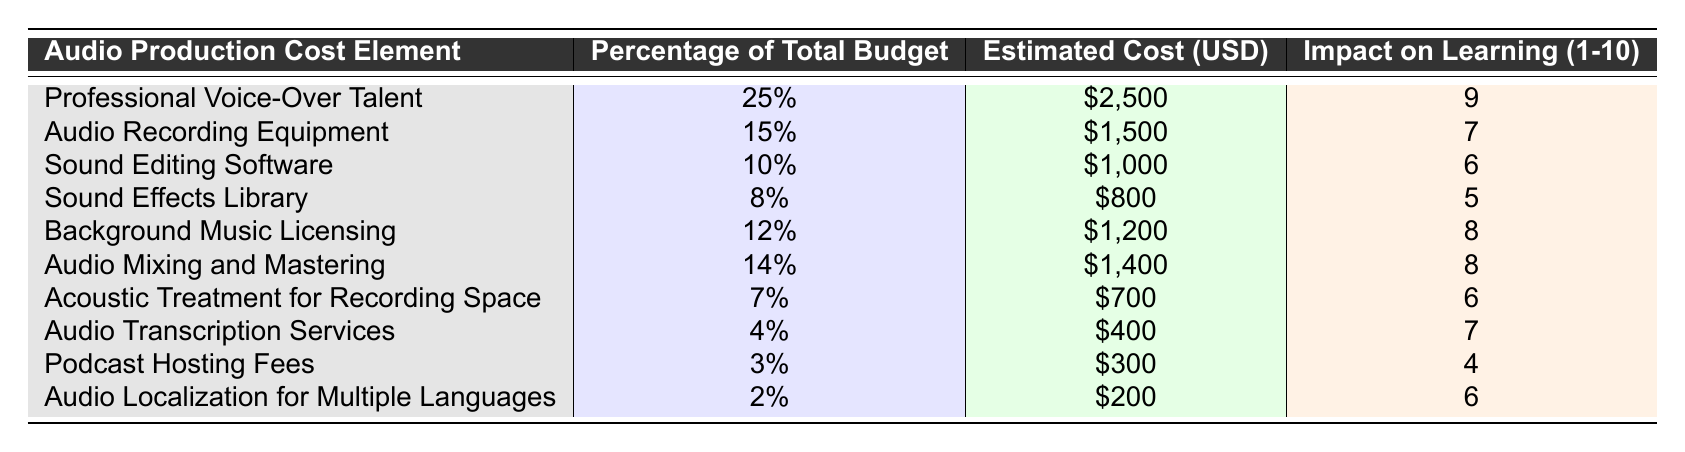What is the estimated cost of Professional Voice-Over Talent? The table shows that the estimated cost for Professional Voice-Over Talent is listed under the "Estimated Cost (USD)" column. It indicates $2,500 for this category.
Answer: $2,500 What percentage of the total budget is allocated to Background Music Licensing? By looking at the "Percentage of Total Budget" column for Background Music Licensing, it states 12%.
Answer: 12% Which audio production cost element has the lowest impact on learning effectiveness? The "Impact on Learning Effectiveness" column indicates that the Podcast Hosting Fees have an impact rating of 4, which is the lowest compared to other elements.
Answer: Podcast Hosting Fees What is the total estimated cost for all audio production elements? To find the total estimated cost, we sum all the values in the "Estimated Cost (USD)" column: 2500 + 1500 + 1000 + 800 + 1200 + 1400 + 700 + 400 + 300 + 200 = 10400.
Answer: $10,400 Is the cost of Audio Localization greater than the cost of Sound Editing Software? Comparing the two values in the "Estimated Cost (USD)" column: Audio Localization is $200 and Sound Editing Software is $1,000. Since $200 is less than $1,000, the answer is no.
Answer: No What is the average impact on learning effectiveness across all audio production elements? To calculate the average, we sum the impact ratings: 9 + 7 + 6 + 5 + 8 + 8 + 6 + 7 + 4 + 6 = 66. Dividing by the 10 elements gives an average of 66/10 = 6.6.
Answer: 6.6 Which audio production cost element has a higher percentage of the total budget: Audio Mixing and Mastering or Sound Effects Library? By comparing the percentages in the "Percentage of Total Budget" column: Audio Mixing and Mastering is 14% and Sound Effects Library is 8%. Since 14% is greater than 8%, the answer is Audio Mixing and Mastering.
Answer: Audio Mixing and Mastering What is the difference in estimated cost between Audio Recording Equipment and Acoustic Treatment for Recording Space? This requires subtracting the estimated costs: $1,500 (Audio Recording Equipment) - $700 (Acoustic Treatment) = $800.
Answer: $800 Are more resources allocated to Professional Voice-Over Talent compared to Audio Localization for Multiple Languages? Looking at the "Estimated Cost (USD)" column: $2,500 for Professional Voice-Over Talent and $200 for Audio Localization. Since $2,500 is greater than $200, the answer is yes.
Answer: Yes If we combine the impacts of Background Music Licensing and Audio Mixing and Mastering, what is the total impact? Adding the impact ratings of these two elements: 8 (Background Music Licensing) + 8 (Audio Mixing and Mastering) equals 16.
Answer: 16 How much of the budget is dedicated to the combination of Audio Mixing and Mastering and Sound Effects Library? We find the percentages: Audio Mixing and Mastering is 14% and Sound Effects Library is 8%. Adding these together gives 14% + 8% = 22%.
Answer: 22% 